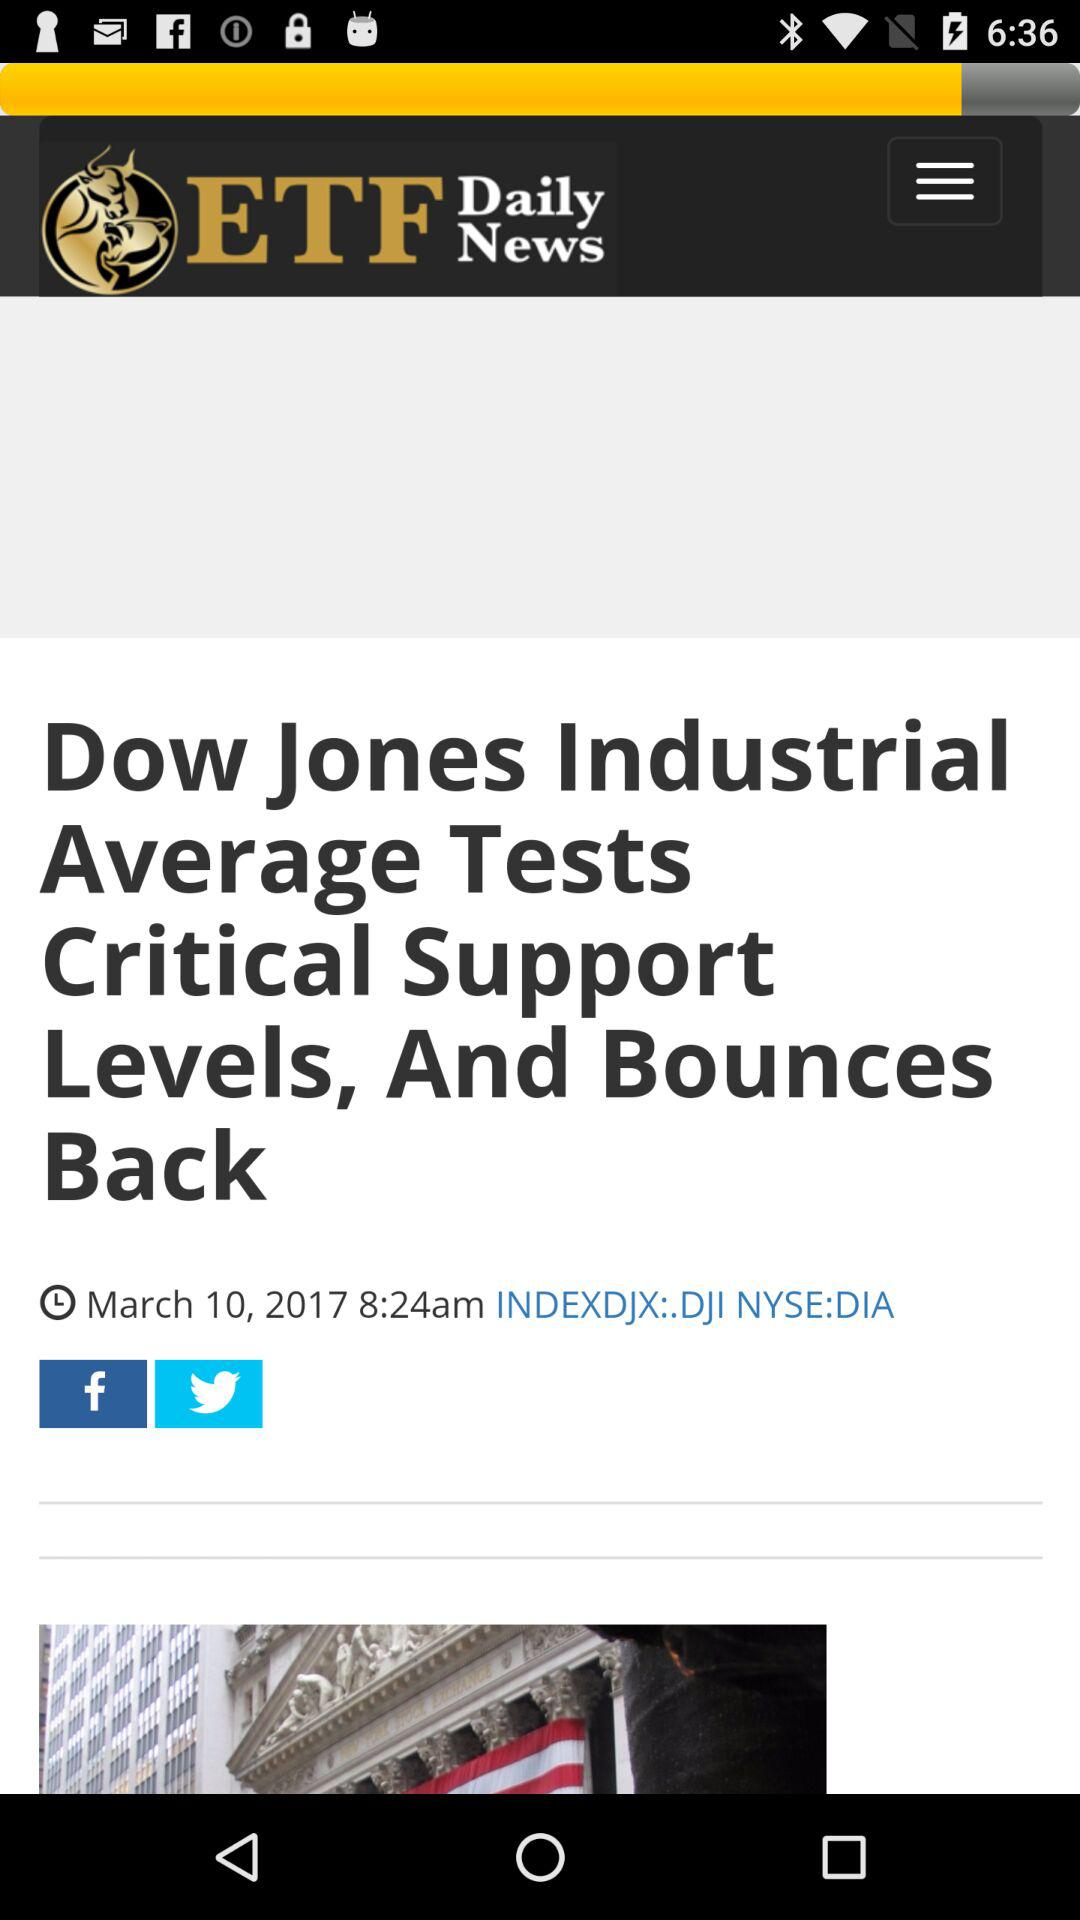Who's the Publisher of the Article?
When the provided information is insufficient, respond with <no answer>. <no answer> 